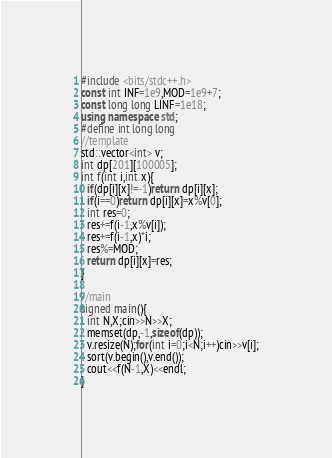Convert code to text. <code><loc_0><loc_0><loc_500><loc_500><_C++_>#include <bits/stdc++.h>
const int INF=1e9,MOD=1e9+7;
const long long LINF=1e18;
using namespace std;
#define int long long
//template
std::vector<int> v;
int dp[201][100005];
int f(int i,int x){
  if(dp[i][x]!=-1)return dp[i][x];
  if(i==0)return dp[i][x]=x%v[0];
  int res=0;
  res+=f(i-1,x%v[i]);
  res+=f(i-1,x)*i;
  res%=MOD;
  return dp[i][x]=res;
}

//main
signed main(){
  int N,X;cin>>N>>X;
  memset(dp,-1,sizeof(dp));
  v.resize(N);for(int i=0;i<N;i++)cin>>v[i];
  sort(v.begin(),v.end());
  cout<<f(N-1,X)<<endl;
}
</code> 